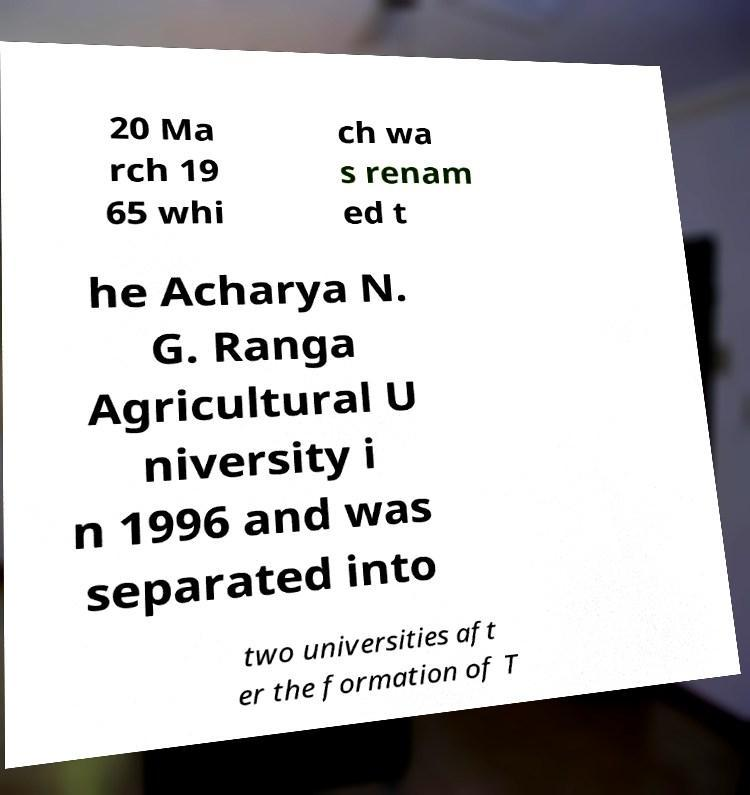Can you read and provide the text displayed in the image?This photo seems to have some interesting text. Can you extract and type it out for me? 20 Ma rch 19 65 whi ch wa s renam ed t he Acharya N. G. Ranga Agricultural U niversity i n 1996 and was separated into two universities aft er the formation of T 